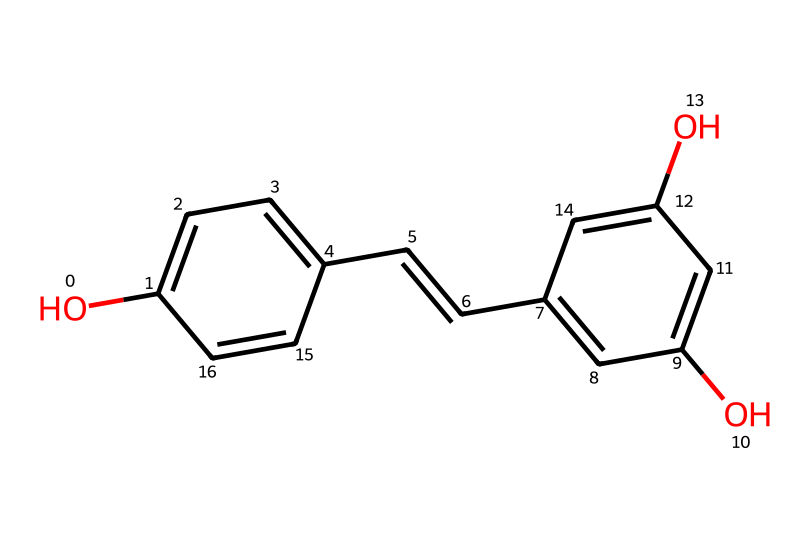What is the main functional group present in resveratrol? The chemical structure depicts hydroxyl groups (-OH) attached to the aromatic rings, which characterizes it as a phenolic compound.
Answer: hydroxyl group How many hydroxyl groups are present in resveratrol? By analyzing the structure, two distinct hydroxyl groups can be identified; one on each aromatic ring.
Answer: two What type of chemical structure is resveratrol classified as? The presence of multiple hydroxyl groups, along with its aromatic nature, indicates that resveratrol is classified as a phenol.
Answer: phenol What is the total number of carbon atoms in resveratrol? Counting the carbon atoms in the structure reveals a total of 14 carbon atoms, both in the rings and the side chains.
Answer: fourteen What kind of double bond is present in resveratrol? The structure shows a double bond between the carbon atoms in the ethylene part of the molecule, indicating it as a trans double bond due to the positioning of the substituents.
Answer: trans How does resveratrol's structure relate to its antioxidant properties? The presence of aromatic rings and hydroxyl groups in the structure allows the compound to act as an electron donor, which is crucial for its antioxidant activity in neutralizing free radicals.
Answer: antioxidant 